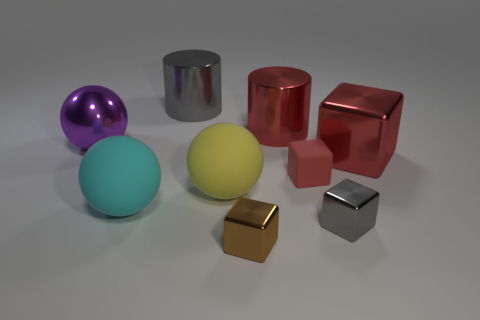Subtract all yellow balls. Subtract all red cylinders. How many balls are left? 2 Add 1 purple metal objects. How many objects exist? 10 Subtract all cylinders. How many objects are left? 7 Subtract 1 brown blocks. How many objects are left? 8 Subtract all large blue cubes. Subtract all brown metallic blocks. How many objects are left? 8 Add 5 big metallic cylinders. How many big metallic cylinders are left? 7 Add 6 metallic cubes. How many metallic cubes exist? 9 